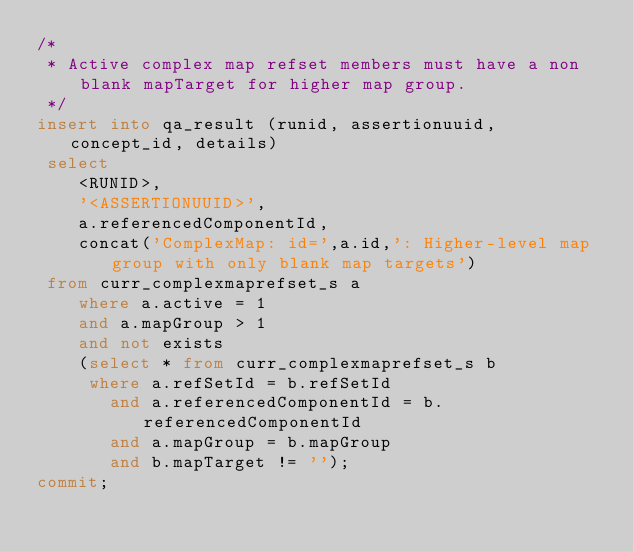Convert code to text. <code><loc_0><loc_0><loc_500><loc_500><_SQL_>/*
 * Active complex map refset members must have a non blank mapTarget for higher map group.
 */
insert into qa_result (runid, assertionuuid, concept_id, details)
 select
 	<RUNID>,
 	'<ASSERTIONUUID>',
	a.referencedComponentId,
 	concat('ComplexMap: id=',a.id,': Higher-level map group with only blank map targets') 
 from curr_complexmaprefset_s a
	where a.active = 1
  	and a.mapGroup > 1
  	and not exists
    (select * from curr_complexmaprefset_s b
     where a.refSetId = b.refSetId
       and a.referencedComponentId = b.referencedComponentId
       and a.mapGroup = b.mapGroup
       and b.mapTarget != '');
commit;</code> 